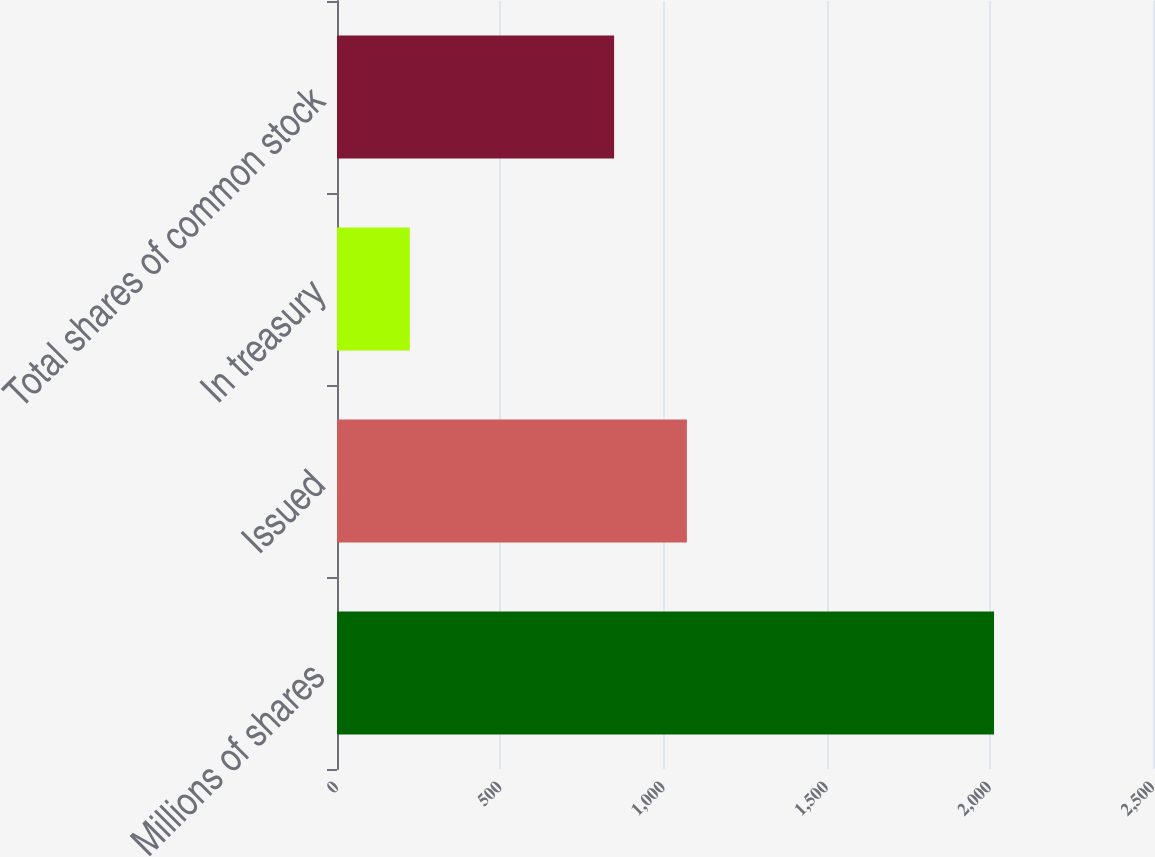<chart> <loc_0><loc_0><loc_500><loc_500><bar_chart><fcel>Millions of shares<fcel>Issued<fcel>In treasury<fcel>Total shares of common stock<nl><fcel>2013<fcel>1072<fcel>223<fcel>849<nl></chart> 